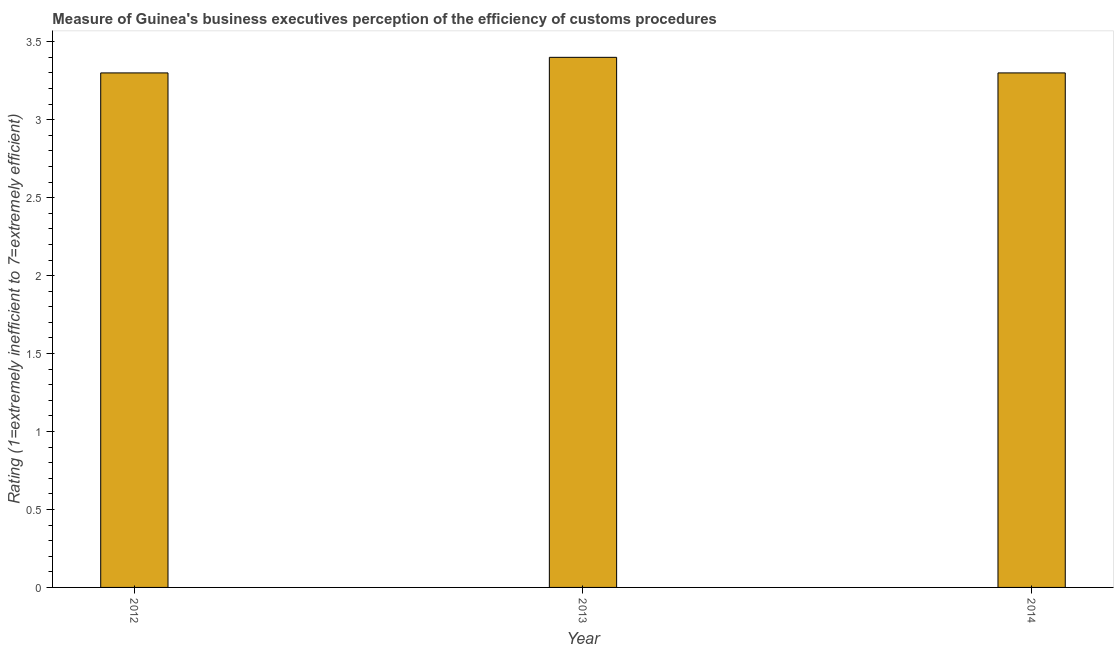Does the graph contain any zero values?
Your answer should be very brief. No. What is the title of the graph?
Give a very brief answer. Measure of Guinea's business executives perception of the efficiency of customs procedures. What is the label or title of the Y-axis?
Make the answer very short. Rating (1=extremely inefficient to 7=extremely efficient). Across all years, what is the maximum rating measuring burden of customs procedure?
Offer a very short reply. 3.4. In which year was the rating measuring burden of customs procedure minimum?
Give a very brief answer. 2012. What is the average rating measuring burden of customs procedure per year?
Your answer should be very brief. 3.33. What is the median rating measuring burden of customs procedure?
Provide a succinct answer. 3.3. In how many years, is the rating measuring burden of customs procedure greater than 1.3 ?
Ensure brevity in your answer.  3. Is the rating measuring burden of customs procedure in 2012 less than that in 2014?
Provide a succinct answer. No. Is the difference between the rating measuring burden of customs procedure in 2012 and 2014 greater than the difference between any two years?
Give a very brief answer. No. In how many years, is the rating measuring burden of customs procedure greater than the average rating measuring burden of customs procedure taken over all years?
Provide a short and direct response. 1. Are all the bars in the graph horizontal?
Your answer should be compact. No. How many years are there in the graph?
Offer a terse response. 3. Are the values on the major ticks of Y-axis written in scientific E-notation?
Keep it short and to the point. No. What is the Rating (1=extremely inefficient to 7=extremely efficient) in 2012?
Keep it short and to the point. 3.3. What is the Rating (1=extremely inefficient to 7=extremely efficient) in 2014?
Your response must be concise. 3.3. What is the difference between the Rating (1=extremely inefficient to 7=extremely efficient) in 2012 and 2013?
Provide a short and direct response. -0.1. What is the difference between the Rating (1=extremely inefficient to 7=extremely efficient) in 2012 and 2014?
Ensure brevity in your answer.  0. What is the ratio of the Rating (1=extremely inefficient to 7=extremely efficient) in 2012 to that in 2013?
Your response must be concise. 0.97. What is the ratio of the Rating (1=extremely inefficient to 7=extremely efficient) in 2012 to that in 2014?
Provide a short and direct response. 1. 